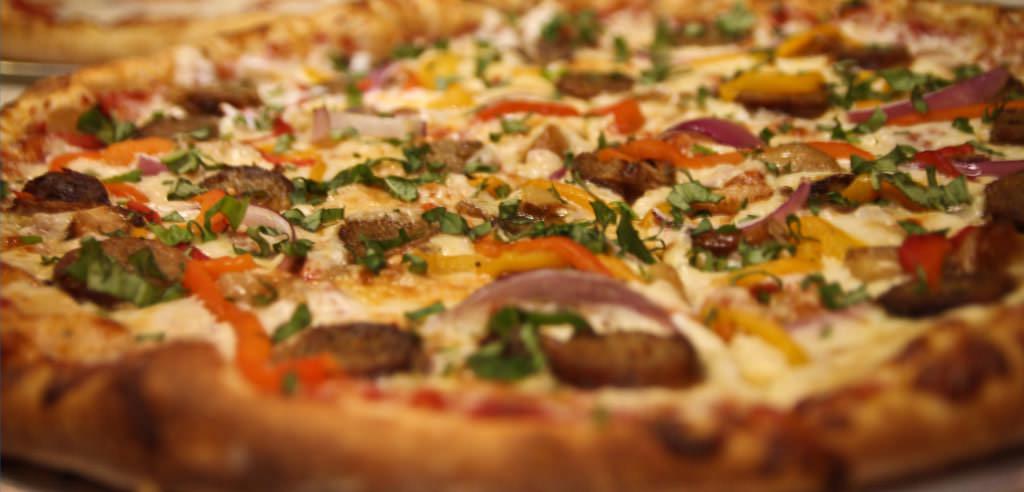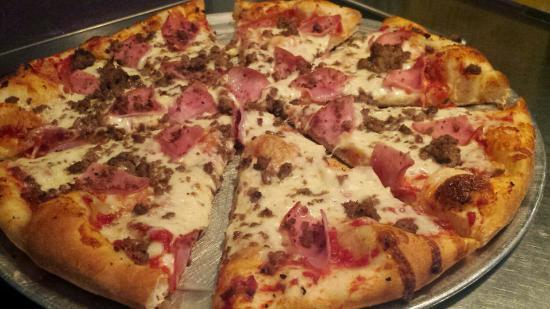The first image is the image on the left, the second image is the image on the right. For the images shown, is this caption "There are red peppers on exactly one pizza." true? Answer yes or no. Yes. The first image is the image on the left, the second image is the image on the right. For the images displayed, is the sentence "Part of a round metal tray is visible between at least two slices of pizza in the right image." factually correct? Answer yes or no. Yes. 